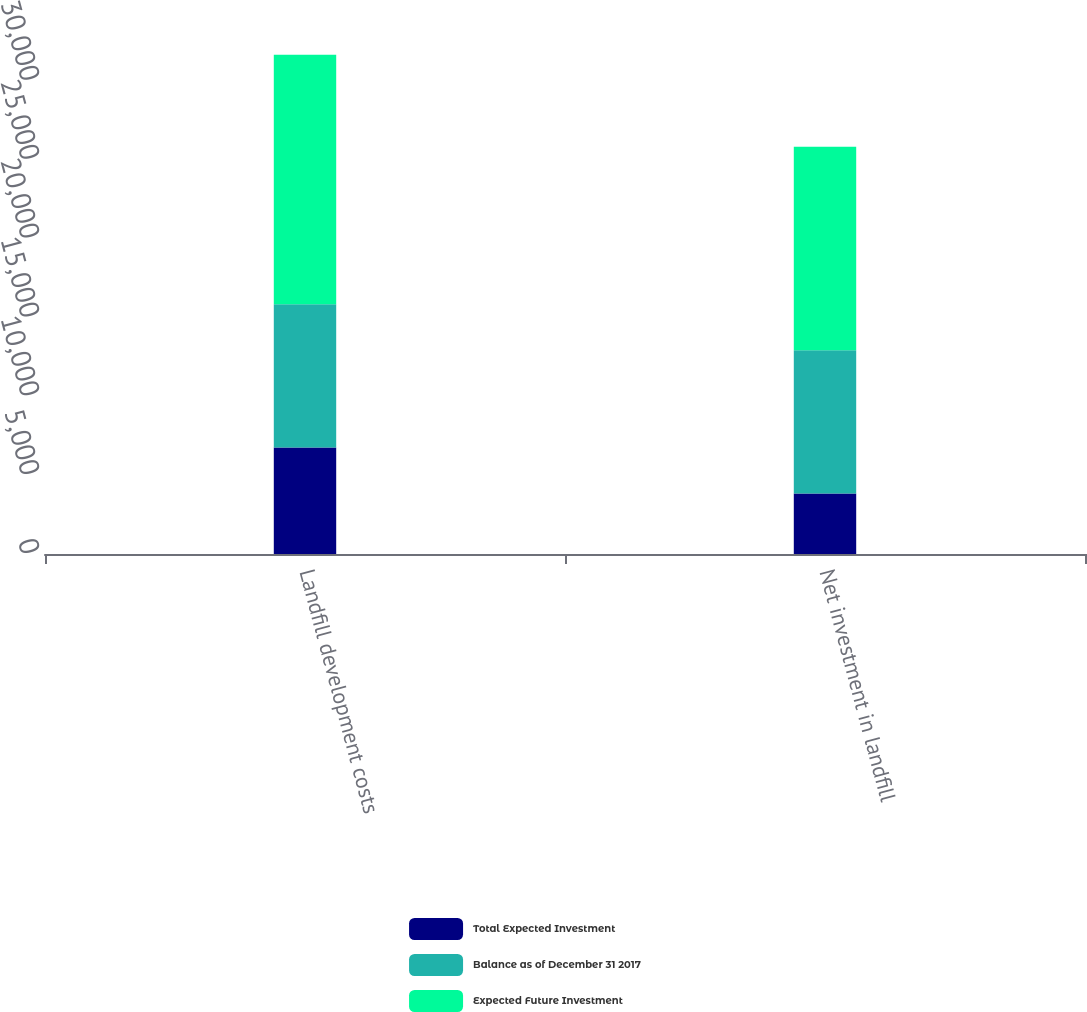<chart> <loc_0><loc_0><loc_500><loc_500><stacked_bar_chart><ecel><fcel>Landfill development costs<fcel>Net investment in landfill<nl><fcel>Total Expected Investment<fcel>6757.3<fcel>3840.1<nl><fcel>Balance as of December 31 2017<fcel>9071.8<fcel>9071.8<nl><fcel>Expected Future Investment<fcel>15829.1<fcel>12911.9<nl></chart> 